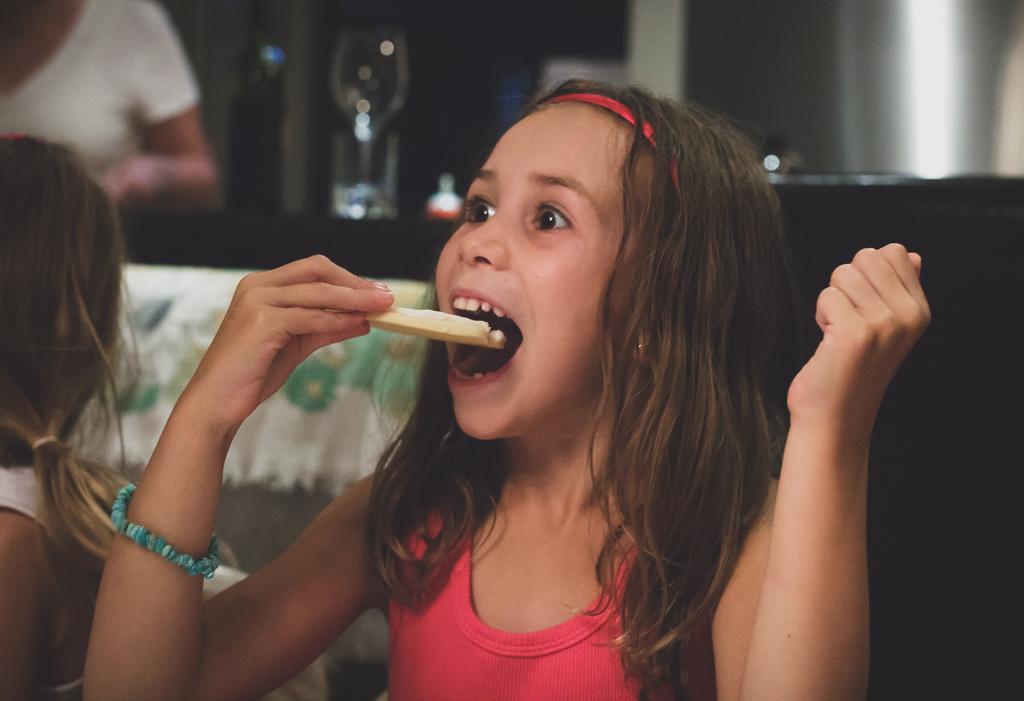Describe this image in one or two sentences. There is a kid kept her mouth opened and holding a edible in her hand and there is another kid sitting beside her and there are few other objects behind her. 